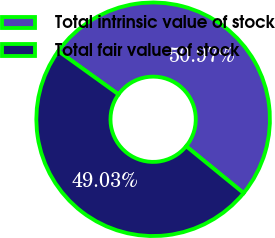Convert chart to OTSL. <chart><loc_0><loc_0><loc_500><loc_500><pie_chart><fcel>Total intrinsic value of stock<fcel>Total fair value of stock<nl><fcel>50.97%<fcel>49.03%<nl></chart> 